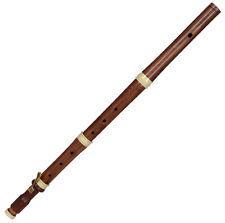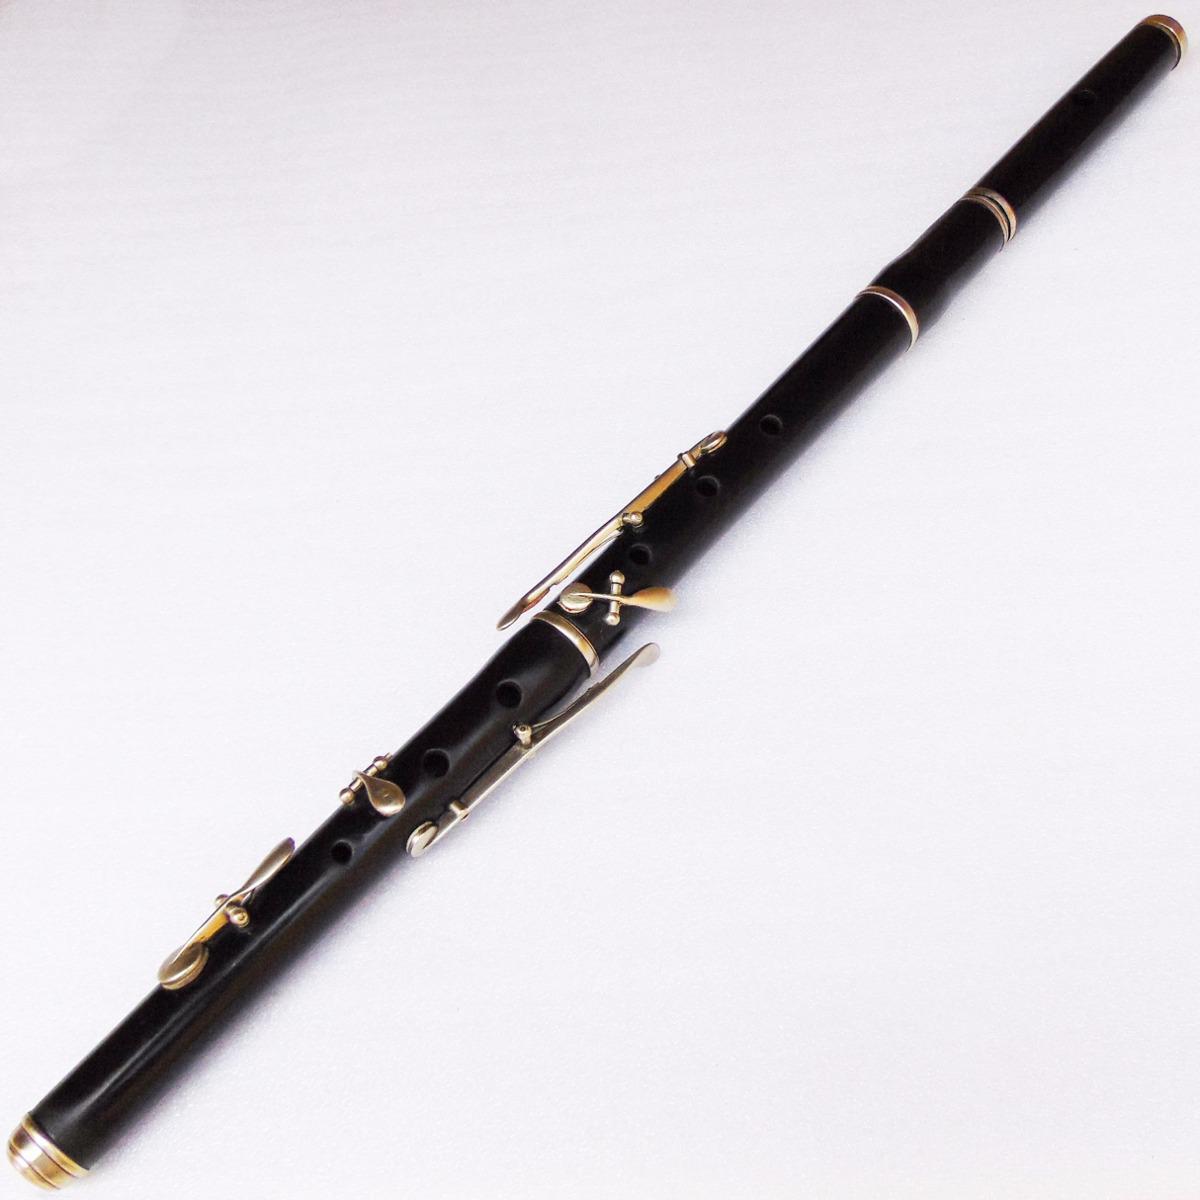The first image is the image on the left, the second image is the image on the right. Assess this claim about the two images: "One image contains at least three flute pieces displayed in a diagonal, non-touching row, and the other image features one diagonal tube shape with a single hole on its surface.". Correct or not? Answer yes or no. No. The first image is the image on the left, the second image is the image on the right. Given the left and right images, does the statement "In one of the images, there are 3 sections of flute laying parallel to each other." hold true? Answer yes or no. No. 